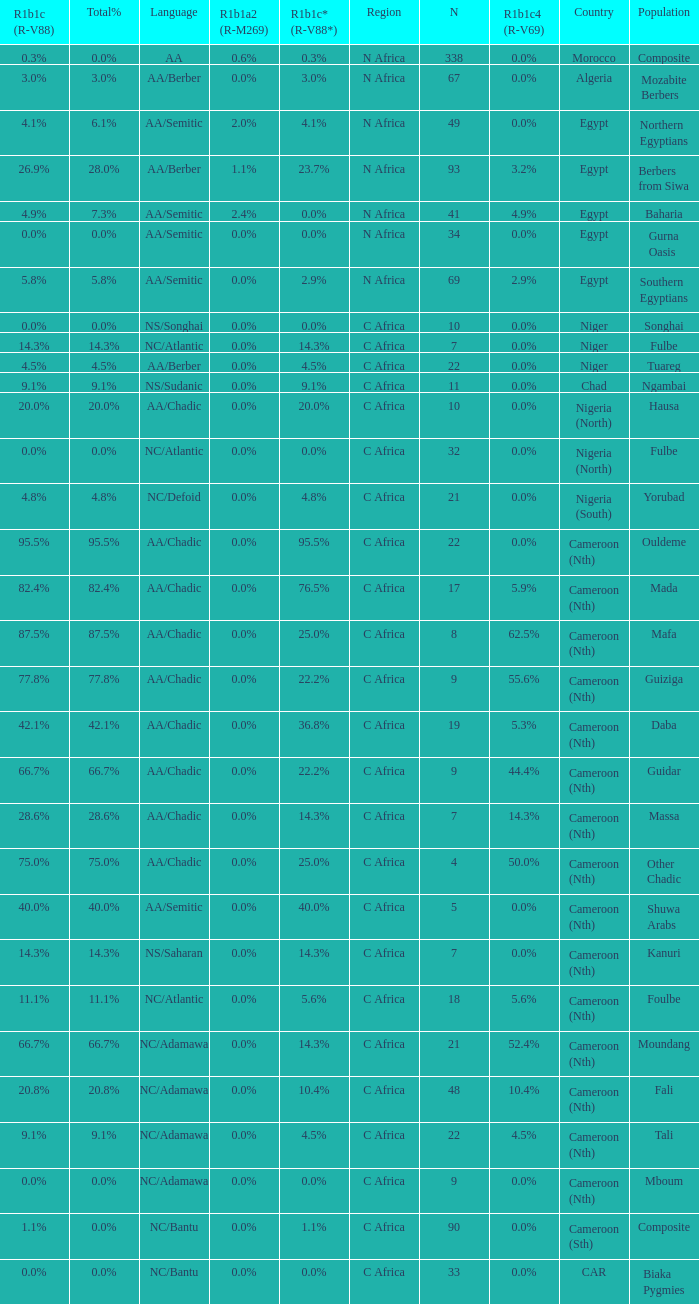How many n are listed for 0.6% r1b1a2 (r-m269)? 1.0. 